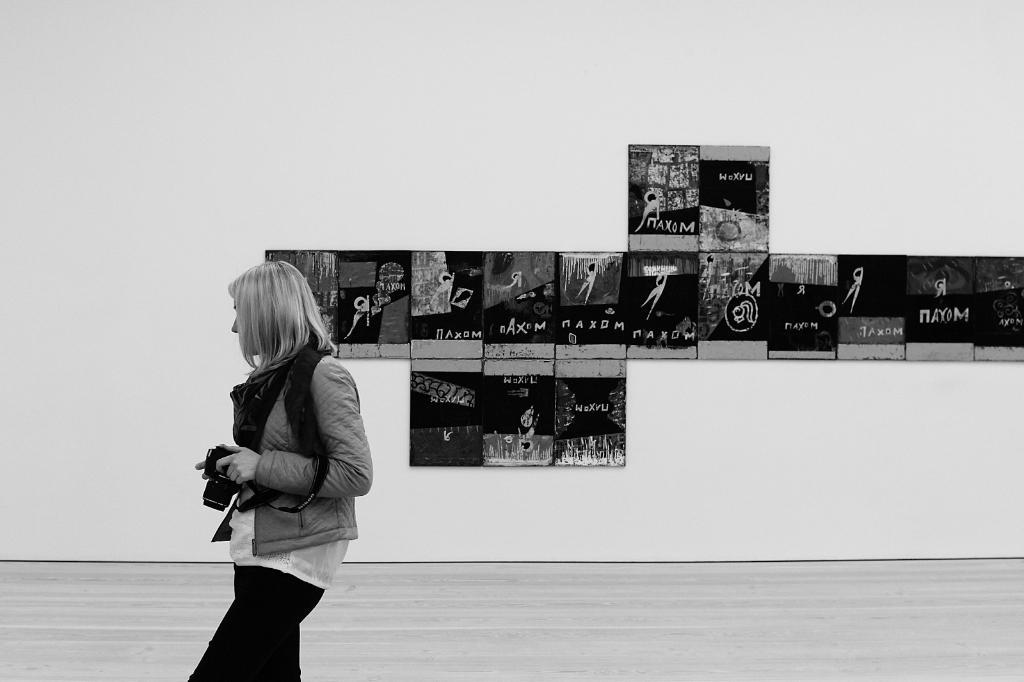What is the color scheme of the image? The image is black and white. Who is present in the image? There is a woman in the image. What is the woman doing in the image? The woman is standing and holding a camera. What can be seen in the background of the image? There are photo frames on the wall in the background of the image. What type of hat is the woman wearing in the image? There is no hat visible in the image; the woman is not wearing a hat. What color is the vest the woman is wearing in the image? There is no vest visible in the image; the woman is not wearing a vest. 